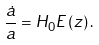Convert formula to latex. <formula><loc_0><loc_0><loc_500><loc_500>\frac { \dot { a } } { a } = H _ { 0 } E \left ( z \right ) .</formula> 